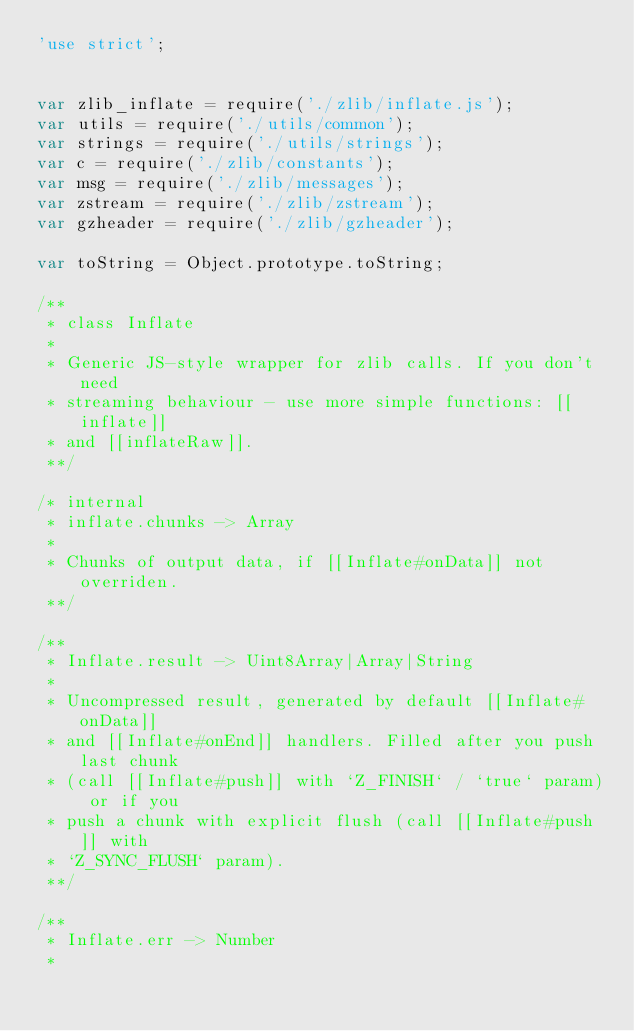<code> <loc_0><loc_0><loc_500><loc_500><_JavaScript_>'use strict';


var zlib_inflate = require('./zlib/inflate.js');
var utils = require('./utils/common');
var strings = require('./utils/strings');
var c = require('./zlib/constants');
var msg = require('./zlib/messages');
var zstream = require('./zlib/zstream');
var gzheader = require('./zlib/gzheader');

var toString = Object.prototype.toString;

/**
 * class Inflate
 *
 * Generic JS-style wrapper for zlib calls. If you don't need
 * streaming behaviour - use more simple functions: [[inflate]]
 * and [[inflateRaw]].
 **/

/* internal
 * inflate.chunks -> Array
 *
 * Chunks of output data, if [[Inflate#onData]] not overriden.
 **/

/**
 * Inflate.result -> Uint8Array|Array|String
 *
 * Uncompressed result, generated by default [[Inflate#onData]]
 * and [[Inflate#onEnd]] handlers. Filled after you push last chunk
 * (call [[Inflate#push]] with `Z_FINISH` / `true` param) or if you
 * push a chunk with explicit flush (call [[Inflate#push]] with
 * `Z_SYNC_FLUSH` param).
 **/

/**
 * Inflate.err -> Number
 *</code> 